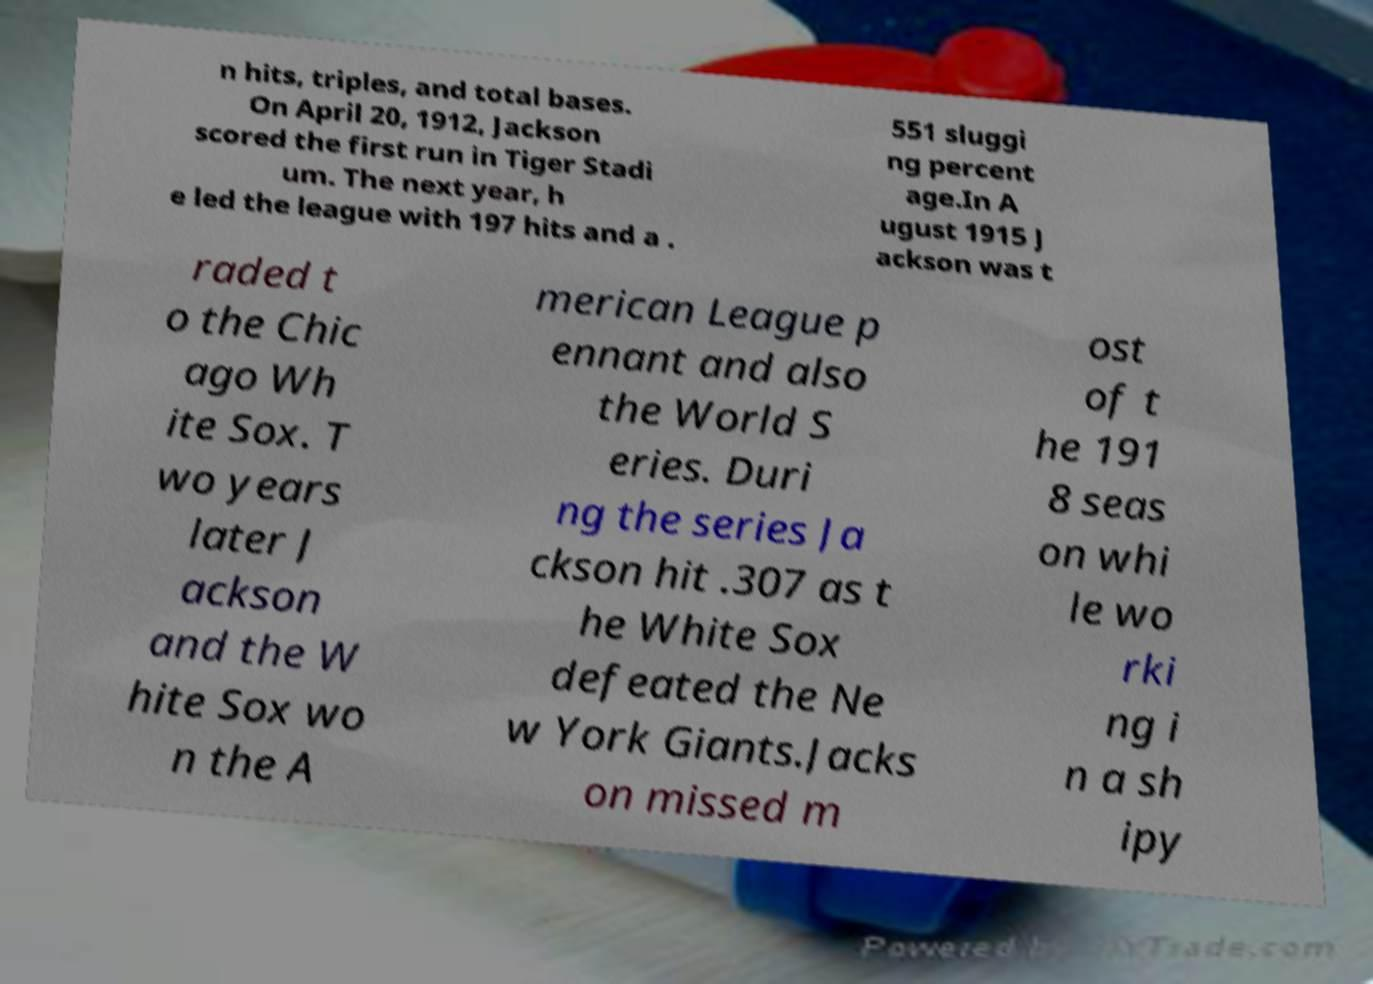Please read and relay the text visible in this image. What does it say? n hits, triples, and total bases. On April 20, 1912, Jackson scored the first run in Tiger Stadi um. The next year, h e led the league with 197 hits and a . 551 sluggi ng percent age.In A ugust 1915 J ackson was t raded t o the Chic ago Wh ite Sox. T wo years later J ackson and the W hite Sox wo n the A merican League p ennant and also the World S eries. Duri ng the series Ja ckson hit .307 as t he White Sox defeated the Ne w York Giants.Jacks on missed m ost of t he 191 8 seas on whi le wo rki ng i n a sh ipy 